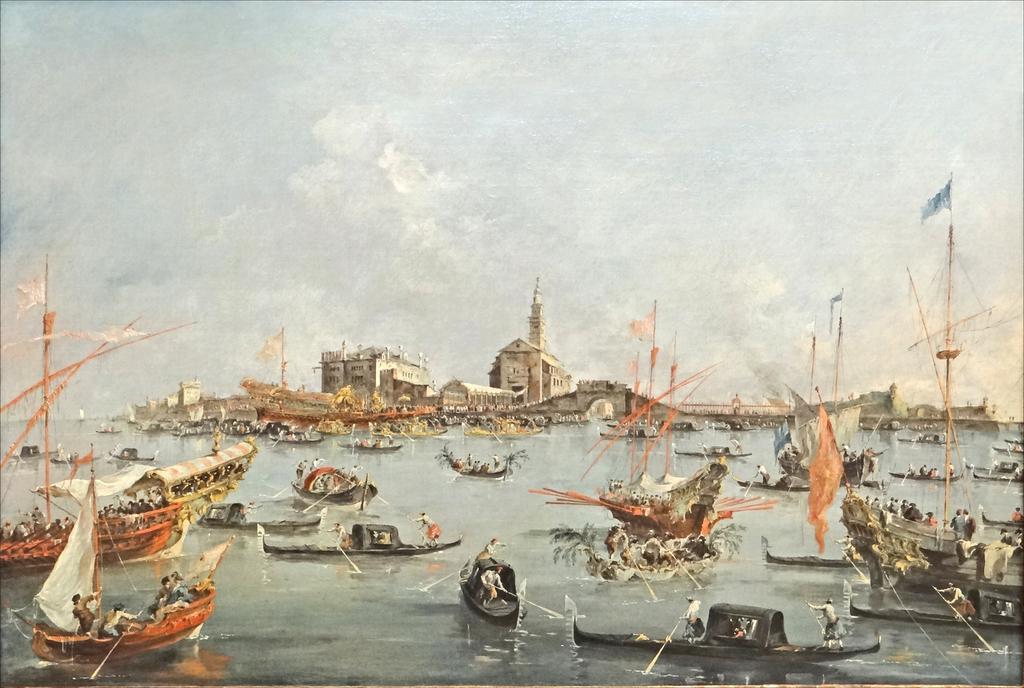Please provide a concise description of this image. In this image, we can see some art of a few boats with people sailing on the water. We can also see some buildings, flags and the sky. 